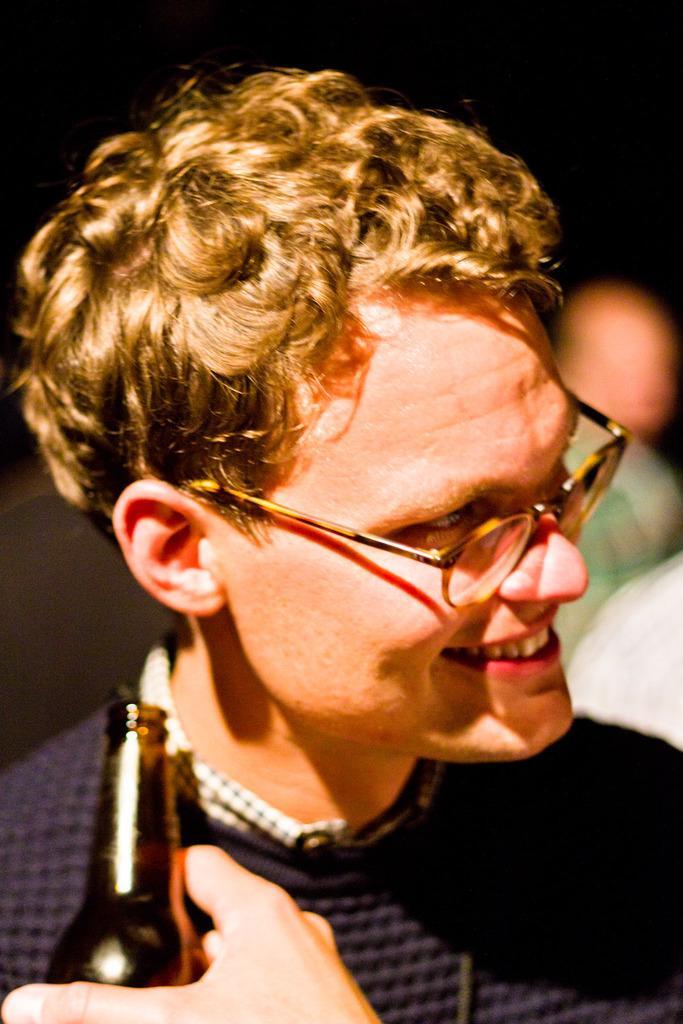Describe this image in one or two sentences. This image consists of a man wearing specs and a blue color shirt. In front of him, there is a person holding a bottle. The background is blurred. 